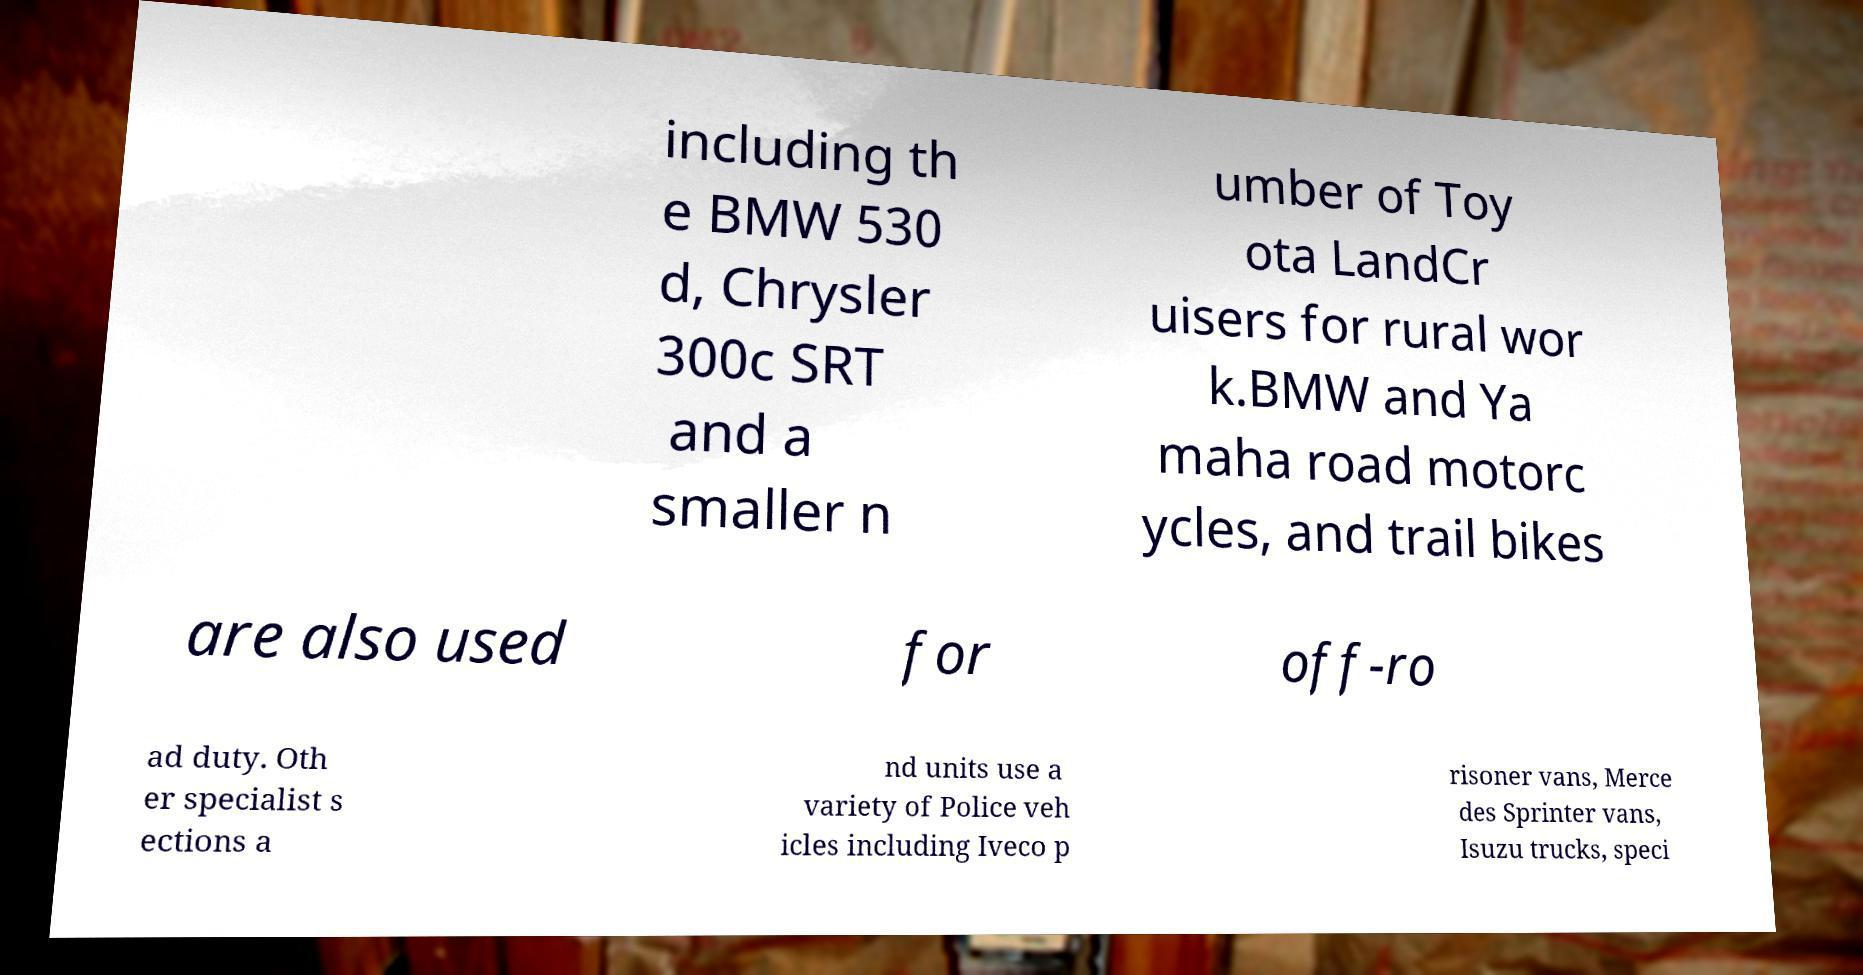Can you accurately transcribe the text from the provided image for me? including th e BMW 530 d, Chrysler 300c SRT and a smaller n umber of Toy ota LandCr uisers for rural wor k.BMW and Ya maha road motorc ycles, and trail bikes are also used for off-ro ad duty. Oth er specialist s ections a nd units use a variety of Police veh icles including Iveco p risoner vans, Merce des Sprinter vans, Isuzu trucks, speci 